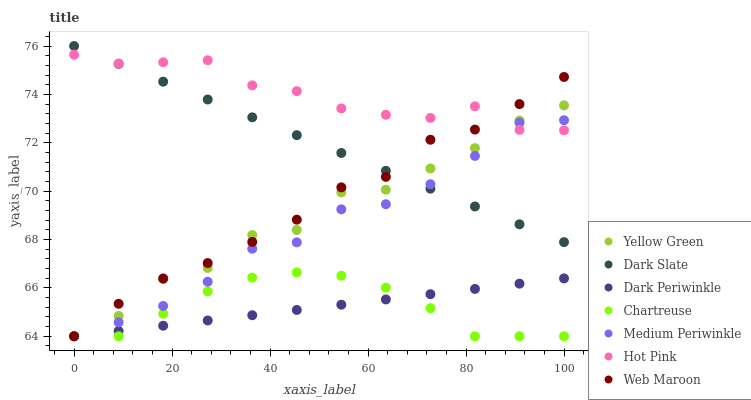Does Dark Periwinkle have the minimum area under the curve?
Answer yes or no. Yes. Does Hot Pink have the maximum area under the curve?
Answer yes or no. Yes. Does Web Maroon have the minimum area under the curve?
Answer yes or no. No. Does Web Maroon have the maximum area under the curve?
Answer yes or no. No. Is Dark Periwinkle the smoothest?
Answer yes or no. Yes. Is Yellow Green the roughest?
Answer yes or no. Yes. Is Web Maroon the smoothest?
Answer yes or no. No. Is Web Maroon the roughest?
Answer yes or no. No. Does Yellow Green have the lowest value?
Answer yes or no. Yes. Does Hot Pink have the lowest value?
Answer yes or no. No. Does Dark Slate have the highest value?
Answer yes or no. Yes. Does Web Maroon have the highest value?
Answer yes or no. No. Is Dark Periwinkle less than Hot Pink?
Answer yes or no. Yes. Is Dark Slate greater than Dark Periwinkle?
Answer yes or no. Yes. Does Web Maroon intersect Yellow Green?
Answer yes or no. Yes. Is Web Maroon less than Yellow Green?
Answer yes or no. No. Is Web Maroon greater than Yellow Green?
Answer yes or no. No. Does Dark Periwinkle intersect Hot Pink?
Answer yes or no. No. 